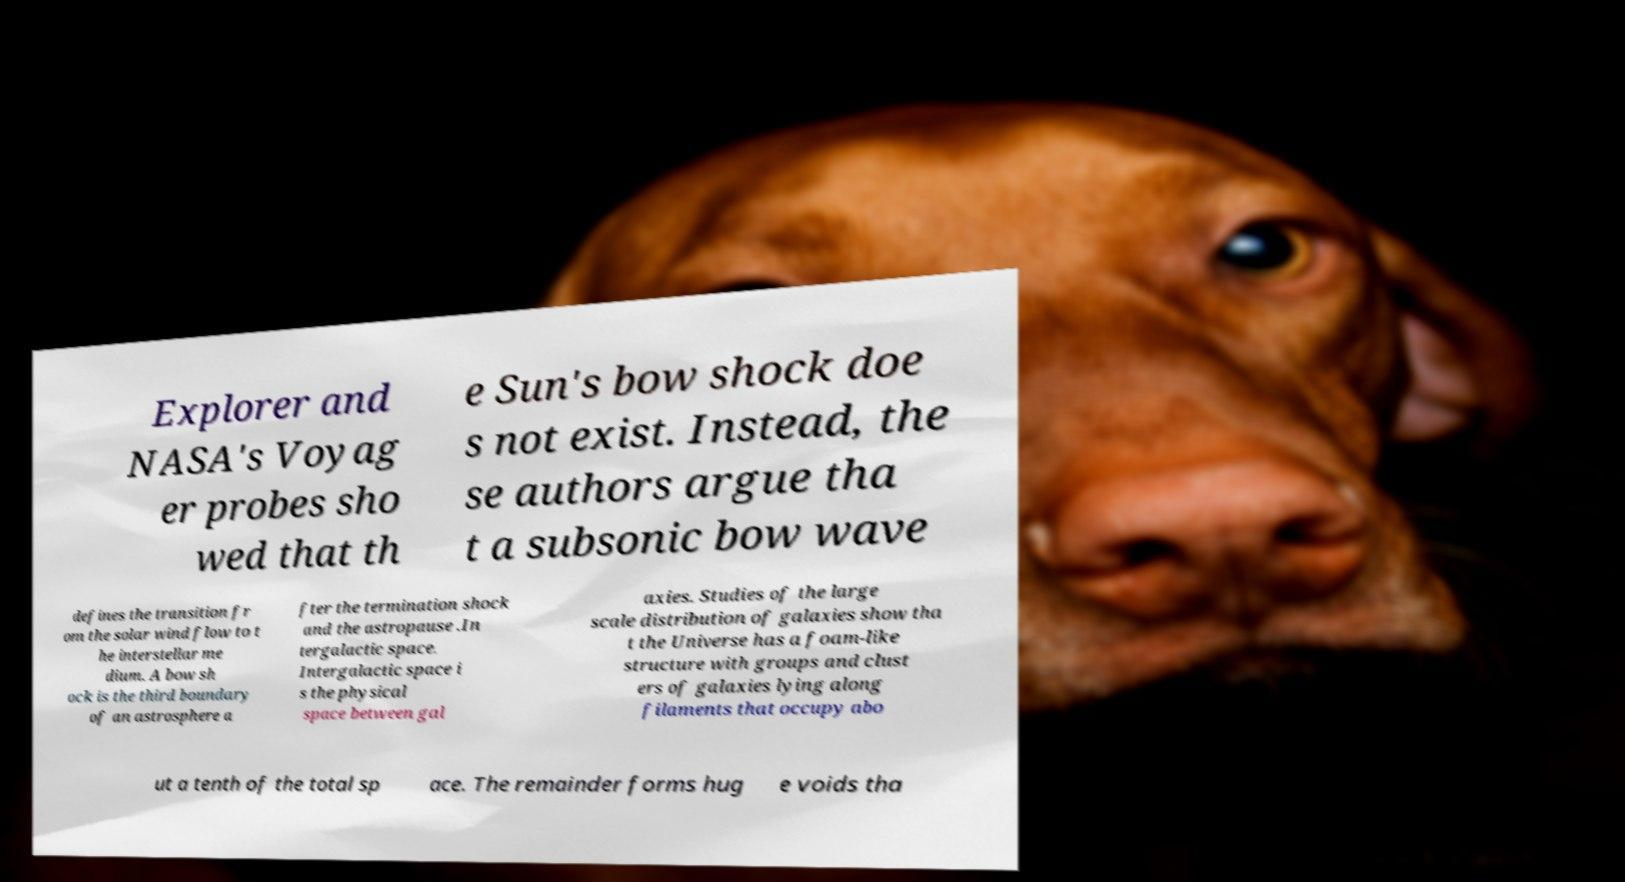Please read and relay the text visible in this image. What does it say? Explorer and NASA's Voyag er probes sho wed that th e Sun's bow shock doe s not exist. Instead, the se authors argue tha t a subsonic bow wave defines the transition fr om the solar wind flow to t he interstellar me dium. A bow sh ock is the third boundary of an astrosphere a fter the termination shock and the astropause .In tergalactic space. Intergalactic space i s the physical space between gal axies. Studies of the large scale distribution of galaxies show tha t the Universe has a foam-like structure with groups and clust ers of galaxies lying along filaments that occupy abo ut a tenth of the total sp ace. The remainder forms hug e voids tha 